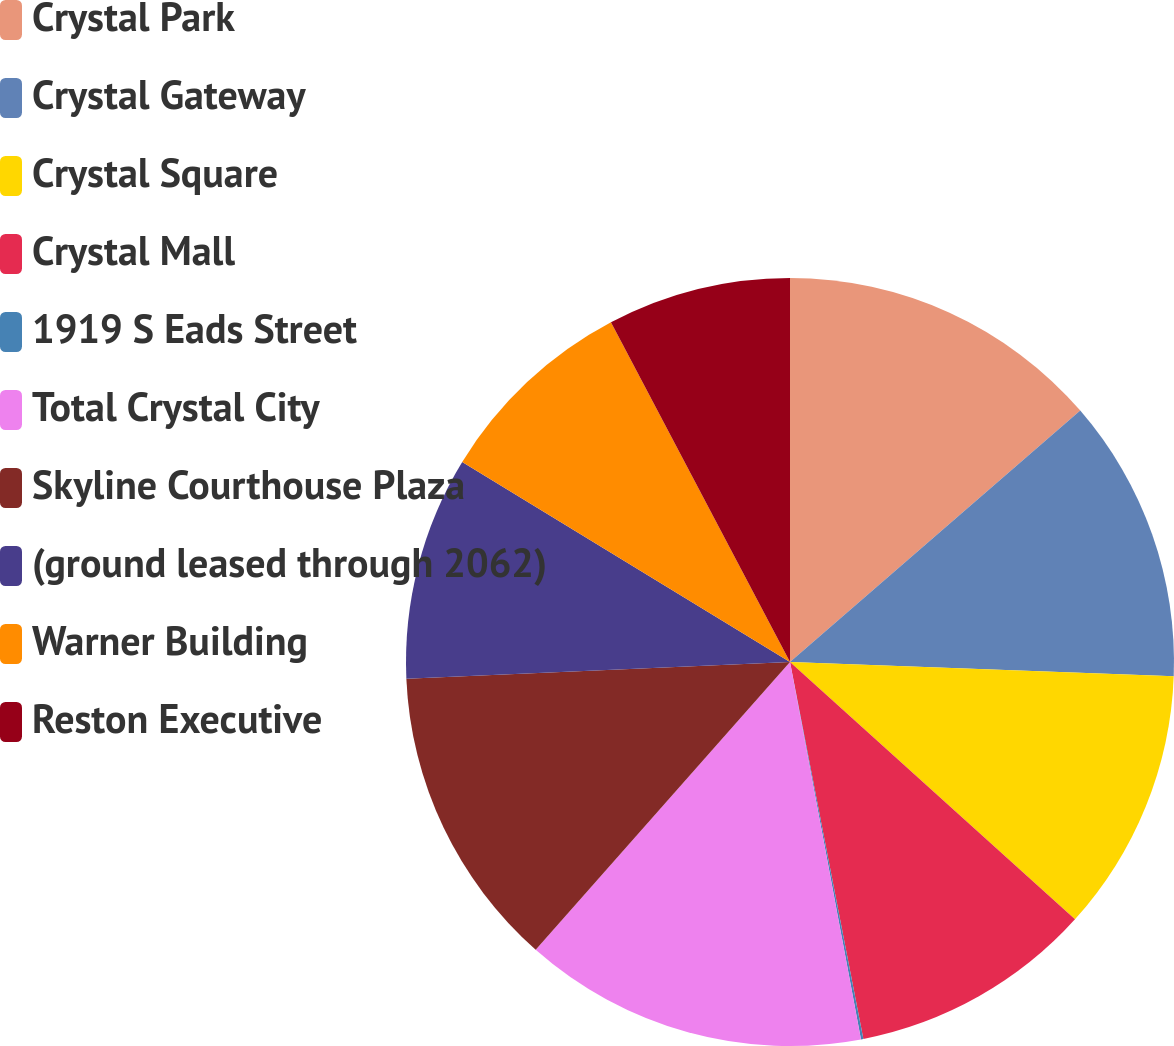<chart> <loc_0><loc_0><loc_500><loc_500><pie_chart><fcel>Crystal Park<fcel>Crystal Gateway<fcel>Crystal Square<fcel>Crystal Mall<fcel>1919 S Eads Street<fcel>Total Crystal City<fcel>Skyline Courthouse Plaza<fcel>(ground leased through 2062)<fcel>Warner Building<fcel>Reston Executive<nl><fcel>13.64%<fcel>11.95%<fcel>11.1%<fcel>10.25%<fcel>0.1%<fcel>14.48%<fcel>12.79%<fcel>9.41%<fcel>8.56%<fcel>7.72%<nl></chart> 